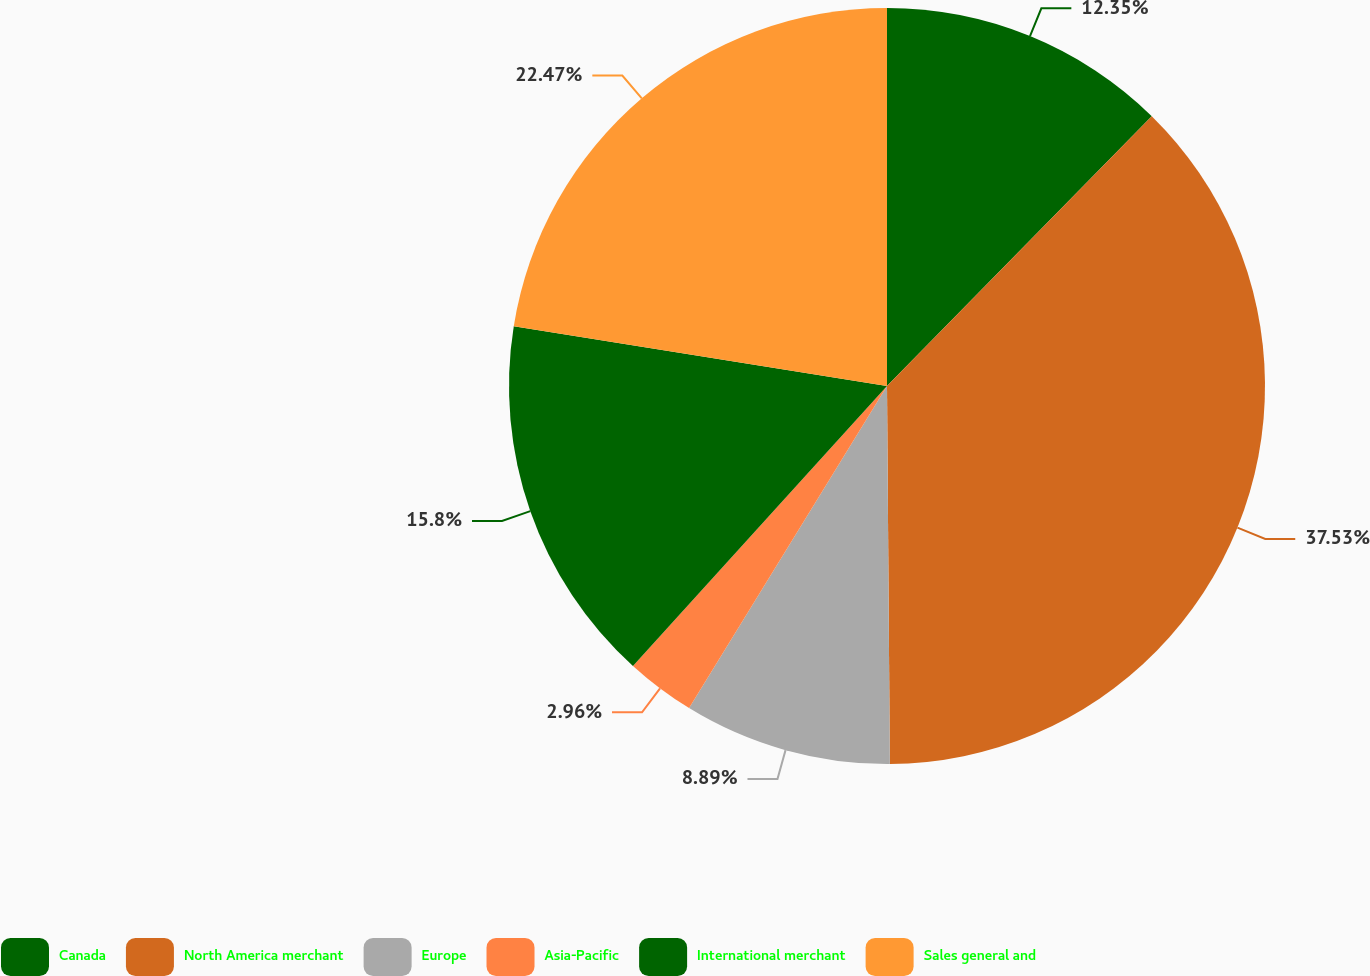<chart> <loc_0><loc_0><loc_500><loc_500><pie_chart><fcel>Canada<fcel>North America merchant<fcel>Europe<fcel>Asia-Pacific<fcel>International merchant<fcel>Sales general and<nl><fcel>12.35%<fcel>37.53%<fcel>8.89%<fcel>2.96%<fcel>15.8%<fcel>22.47%<nl></chart> 